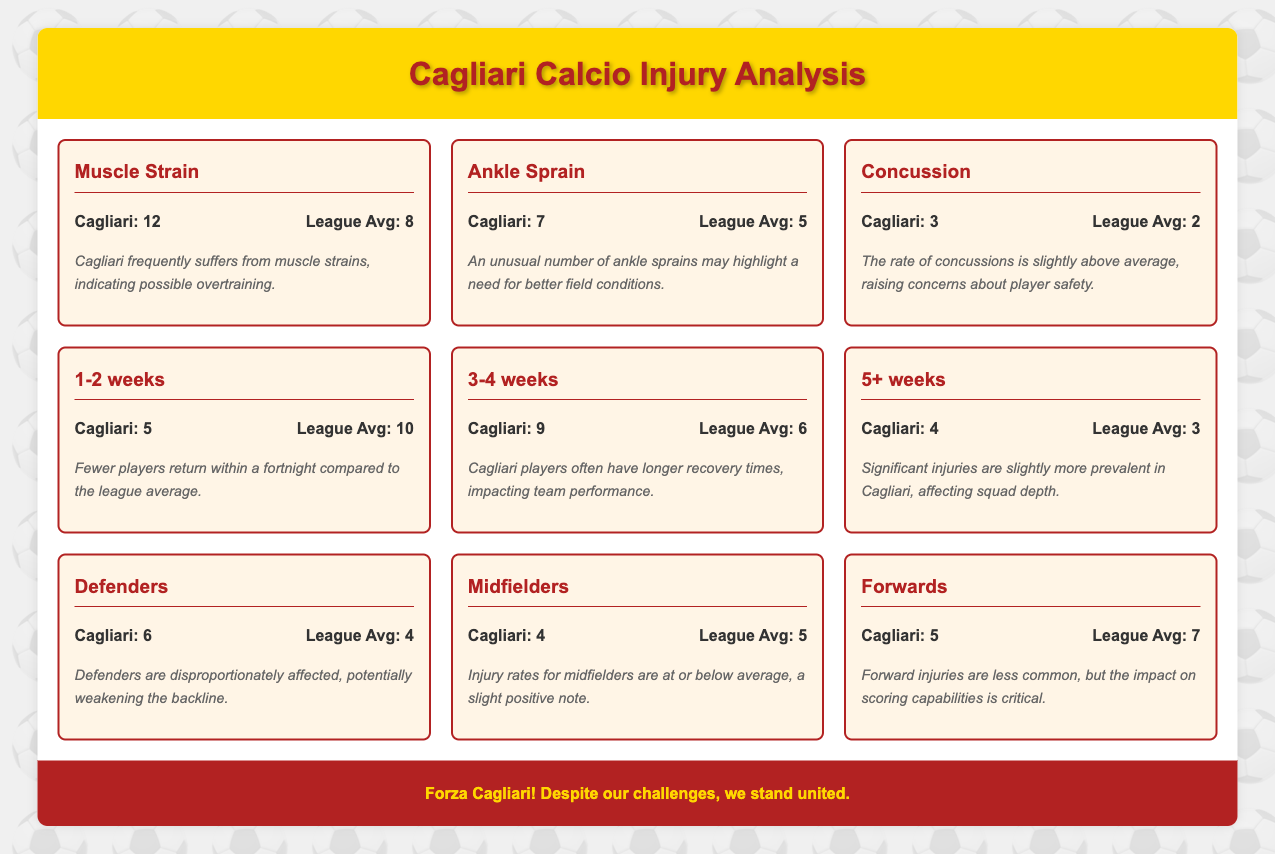What is the count of Muscle Strains for Cagliari? The table indicates that Cagliari has a count of 12 Muscle Strains. This information is retrieved directly from the "Muscle Strain" row in the Injury Types category.
Answer: 12 How does Cagliari's count for Ankle Sprains compare to the league average? Cagliari has 7 Ankle Sprains while the league average is 5. Therefore, Cagliari's count is higher than the league average. This is evident by comparing the two values in the Ankle Sprain row.
Answer: Higher What is the total number of injuries (Cagliari count) reported for the duration of 3-4 weeks? The number reported for 3-4 weeks in Cagliari is 9. This is taken directly from the respective row, which specifies injury duration.
Answer: 9 Is it true that Cagliari has more players returning from injuries in the 1-2 weeks category compared to the league average? No, Cagliari has a count of 5 for the 1-2 weeks duration, while the league average is 10. Hence, Cagliari has fewer players returning within that period than the league average. This is confirmed by comparing the two counts for the 1-2 weeks duration.
Answer: No What is the difference in the count of injuries for Cagliari and the league average for 5+ weeks injuries? Cagliari has a count of 4, while the league average is 3. The difference can be calculated by subtracting the league average from Cagliari's count, which is 4 - 3 = 1.
Answer: 1 Considering the categories, which type of injury has the highest count for Cagliari and how does it compare to the league average? Muscle Strain has the highest count of 12 for Cagliari, while the league average is 8. Thus, Cagliari's count is significantly higher than the league average for this injury type. This can be determined by looking at the counts for all injury types and comparing them.
Answer: Muscle Strain, higher What percentage of the total reported Cagliari injuries are focused on Defenders? Cagliari reported a total of 46 injuries (sum of all counts). Among them, 6 were Defenders. The percentage is calculated as (6/46) * 100, which is approximately 13.04%.
Answer: Approximately 13.04% Which position has the lowest injury count for Cagliari and how much lower is it compared to the league average for that position? Midfielders have the lowest count with 4 injuries, while the league average is 5. The difference is 1 injury, indicating that Cagliari has fewer injuries in this position compared to the league average. This can be noted by looking at the counts for Midfielders.
Answer: 1 